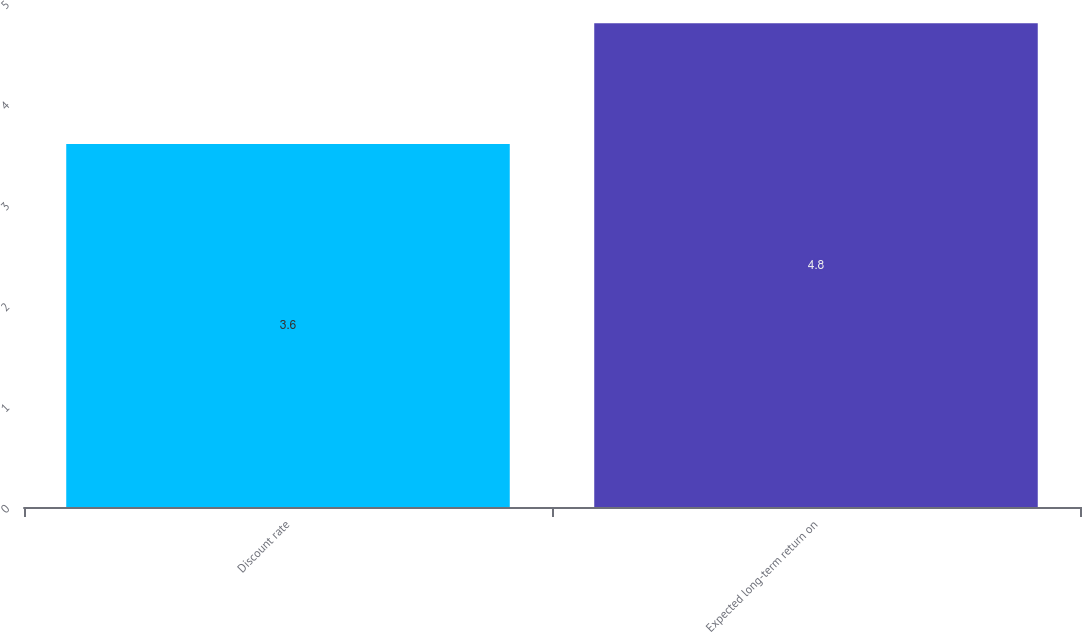Convert chart. <chart><loc_0><loc_0><loc_500><loc_500><bar_chart><fcel>Discount rate<fcel>Expected long-term return on<nl><fcel>3.6<fcel>4.8<nl></chart> 